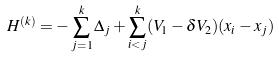Convert formula to latex. <formula><loc_0><loc_0><loc_500><loc_500>H ^ { ( k ) } = - \sum _ { j = 1 } ^ { k } \Delta _ { j } + \sum _ { i < j } ^ { k } ( V _ { 1 } - \delta V _ { 2 } ) ( x _ { i } - x _ { j } )</formula> 